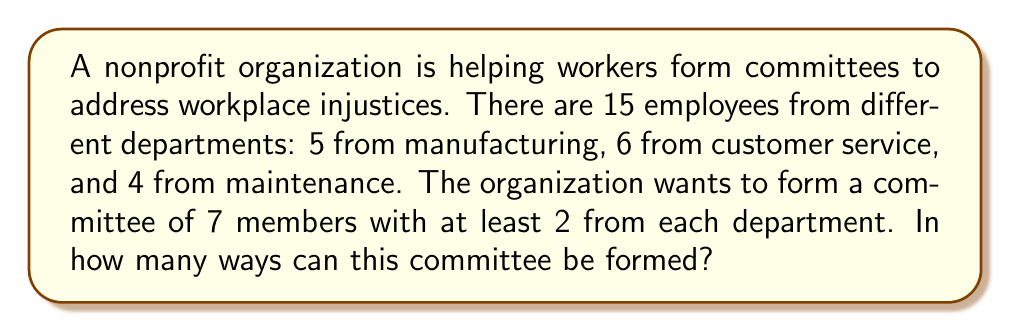Teach me how to tackle this problem. Let's approach this step-by-step using the principle of inclusion-exclusion:

1) First, we need to calculate the total number of ways to choose 7 people from 15:
   $$\binom{15}{7}$$

2) Now, we need to subtract the number of ways that don't include at least 2 from each department. We can do this by subtracting:
   a) Committees with fewer than 2 from manufacturing
   b) Committees with fewer than 2 from customer service
   c) Committees with fewer than 2 from maintenance

3) For manufacturing:
   $$\binom{10}{7} + \binom{10}{6}\binom{5}{1}$$

4) For customer service:
   $$\binom{9}{7} + \binom{9}{6}\binom{6}{1}$$

5) For maintenance:
   $$\binom{11}{7} + \binom{11}{6}\binom{4}{1}$$

6) However, we've now subtracted committees that are missing two departments twice, so we need to add these back:
   $$\binom{6}{7} + \binom{6}{6}\binom{5}{1} + \binom{4}{7} + \binom{4}{6}\binom{6}{1} + \binom{5}{7} + \binom{5}{6}\binom{4}{1}$$

7) The final formula is:

   $$\binom{15}{7} - [\binom{10}{7} + \binom{10}{6}\binom{5}{1} + \binom{9}{7} + \binom{9}{6}\binom{6}{1} + \binom{11}{7} + \binom{11}{6}\binom{4}{1}] + [\binom{6}{7} + \binom{6}{6}\binom{5}{1} + \binom{4}{7} + \binom{4}{6}\binom{6}{1} + \binom{5}{7} + \binom{5}{6}\binom{4}{1}]$$

8) Calculating this:
   $$6435 - [120 + 1050 + 36 + 540 + 330 + 1320] + [0 + 30 + 0 + 0 + 0 + 20] = 3089$$
Answer: 3089 